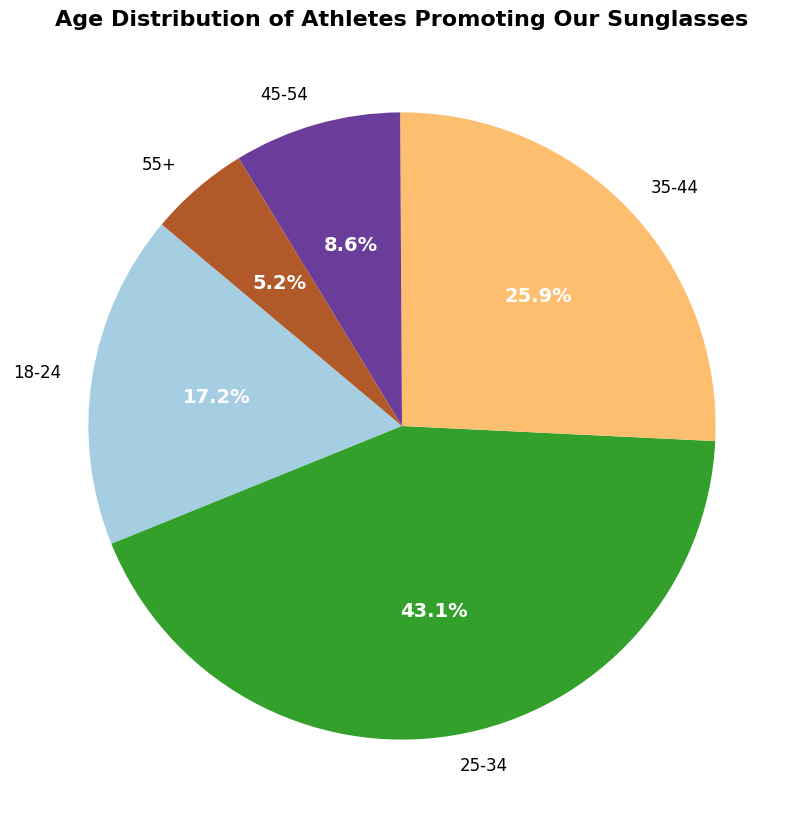What proportion of athletes are aged 18-24? To find this, identify the segment labeled "18-24" on the pie chart. The wedge labeled "18-24" has an autopct value of 16.7%. Therefore, 16.7% of the athletes are aged 18-24.
Answer: 16.7% How many age ranges have more than 10% of the athletes? Visual evidence from the pie chart shows that three wedges (18-24, 25-34, and 35-44) have percentages more than 10%.
Answer: 3 Which age range has the largest group of athletes? From the pie chart, the wedge labeled "25-34" has the largest percentage, indicating it has the most athletes.
Answer: 25-34 What is the combined percentage of athletes aged 45 and older (both 45-54 and 55+ groups)? Sum the percentages of the wedges labeled "45-54" (8.3%) and "55+" (5.0%). Adding these gives 8.3% + 5.0% = 13.3%.
Answer: 13.3% By how much does the largest age group exceed the smallest age group in terms of percentage? The largest age group is "25-34" with 41.7%, and the smallest is "55+" with 5.0%. The difference is 41.7% - 5.0% = 36.7%.
Answer: 36.7% What is the percentage difference between athletes aged 25-34 and those aged 35-44? The "25-34" group has 41.7% and the "35-44" group has 25.0%. The difference is 41.7% - 25.0% = 16.7%.
Answer: 16.7% If the total number of athletes is 58, how many are in the 25-34 age range? Knowing the 25-34 age range represents 41.7% of all athletes, multiply 58 by 0.417 to get the number of athletes. This is 58 * 0.417 ≈ 24.2, which rounds to 24 athletes.
Answer: 24 Which color represents the 35-44 age range on the pie chart? The 35-44 age range is visually represented by one of the colored wedges. Observing the color for the "35-44" label will identify it. As the solution cannot provide an actual image, one must refer to the specified colors in the plot generation code (colors based on the Paired colormap).
Answer: Refer to chart colors What percentage of athletes are younger than 35? Add the percentages of athletes aged 18-24 (16.7%) and 25-34 (41.7%): 16.7% + 41.7% = 58.4%.
Answer: 58.4% 